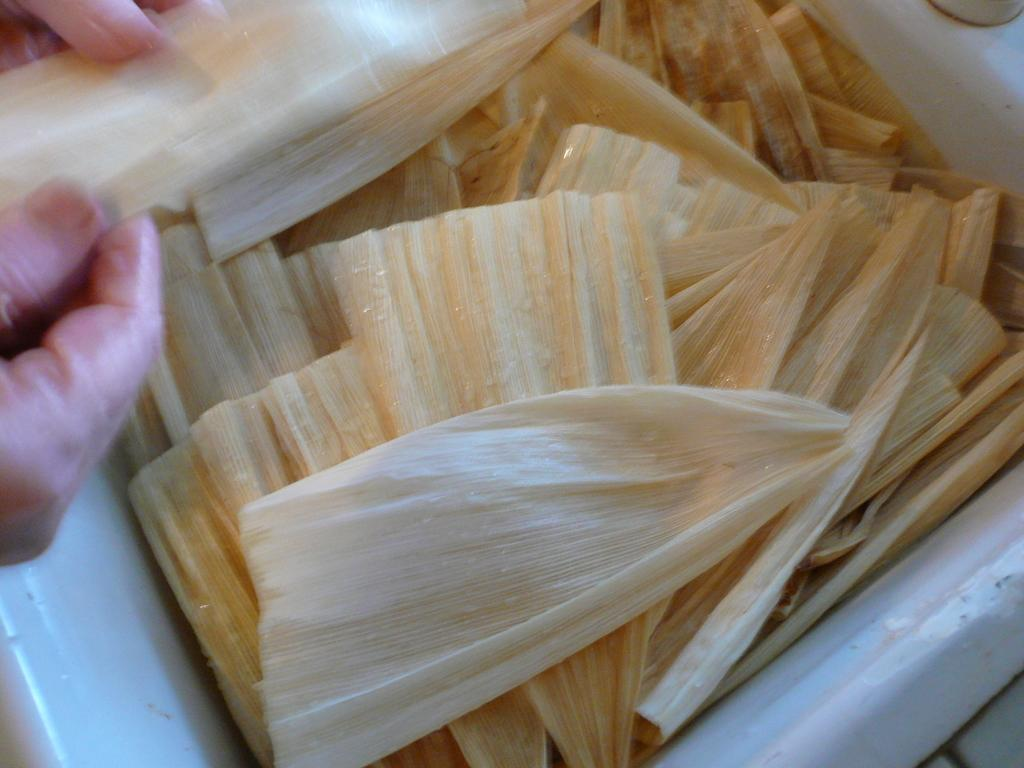What type of food is present in the image? There is cheese in the image. Can you describe any other elements in the image? Yes, there are persons' hands visible in the image. What type of stick is being used to taste the cheese in the image? There is no stick present in the image, and the cheese is not being tasted. Can you see an airplane in the image? No, there is no airplane present in the image. 